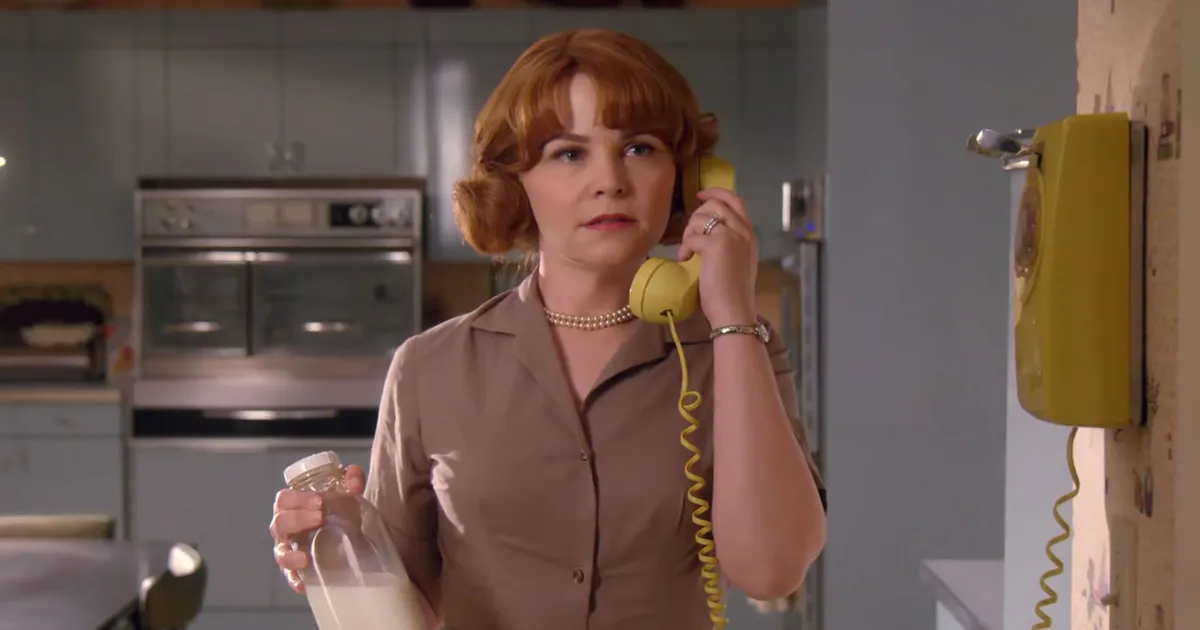What is this photo about? The image depicts a woman from what appears to be a past era, based on the retro kitchen setting and her clothing. She is on a phone call, using a vintage yellow rotary phone, and holding a glass milk bottle, suggesting she might be in the middle of a household errand or a casual conversation. The environment, her dress, and hairstyle evoke a sense of nostalgia and simplicity, typical of mid-20th-century domestic life. 